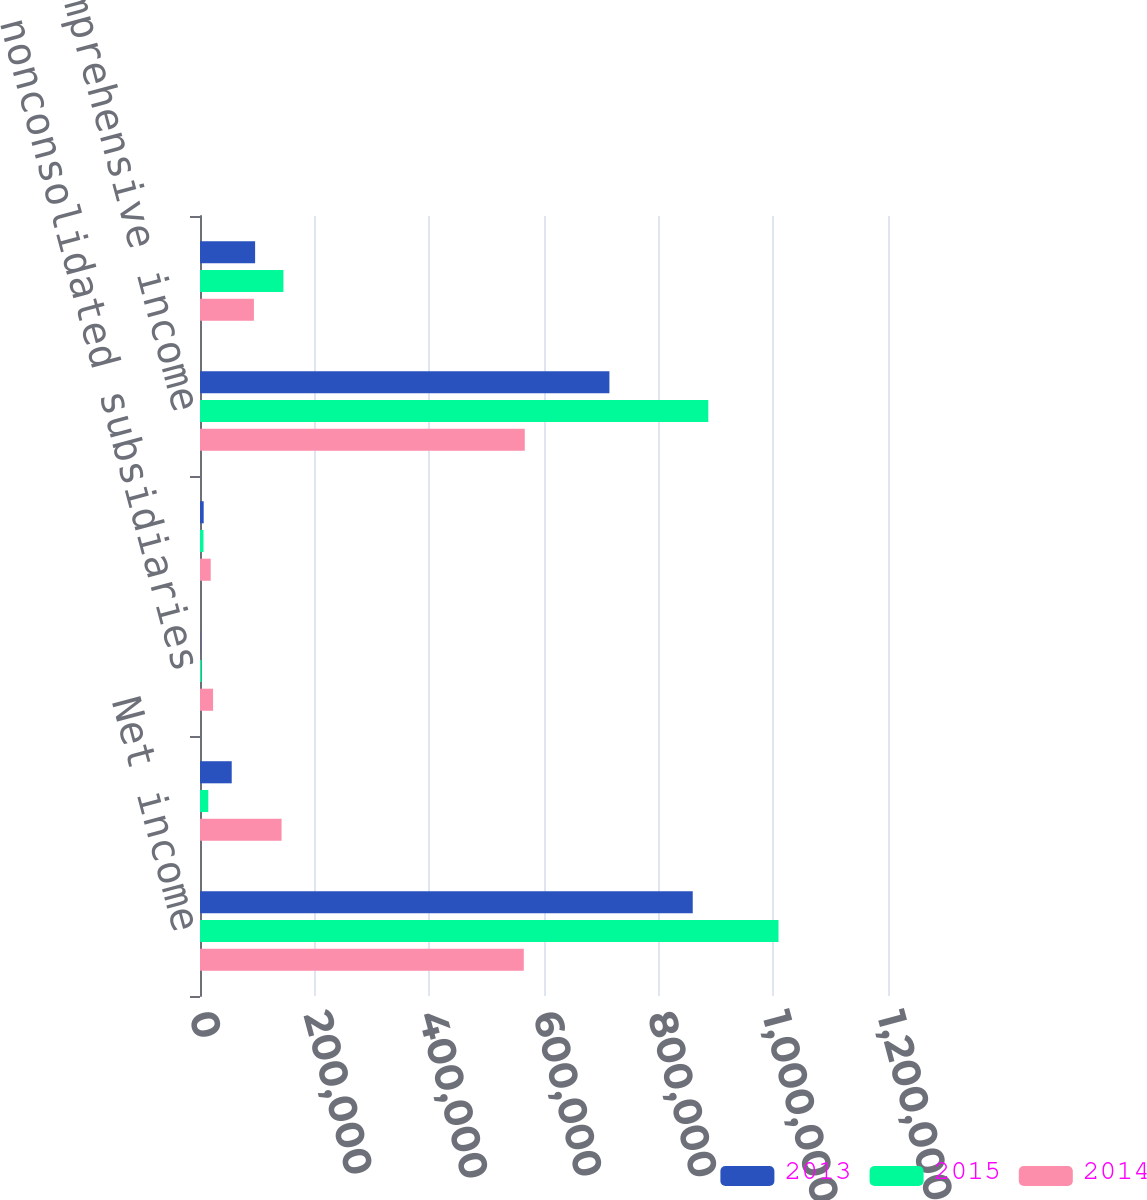Convert chart. <chart><loc_0><loc_0><loc_500><loc_500><stacked_bar_chart><ecel><fcel>Net income<fcel>(Reduction) increase in<fcel>nonconsolidated subsidiaries<fcel>Increase in value of interest<fcel>Comprehensive income<fcel>Less comprehensive income<nl><fcel>2013<fcel>859430<fcel>55326<fcel>327<fcel>6441<fcel>714088<fcel>96130<nl><fcel>2015<fcel>1.00903e+06<fcel>14465<fcel>2509<fcel>6079<fcel>886582<fcel>145497<nl><fcel>2014<fcel>564740<fcel>142281<fcel>22814<fcel>18716<fcel>566454<fcel>94065<nl></chart> 